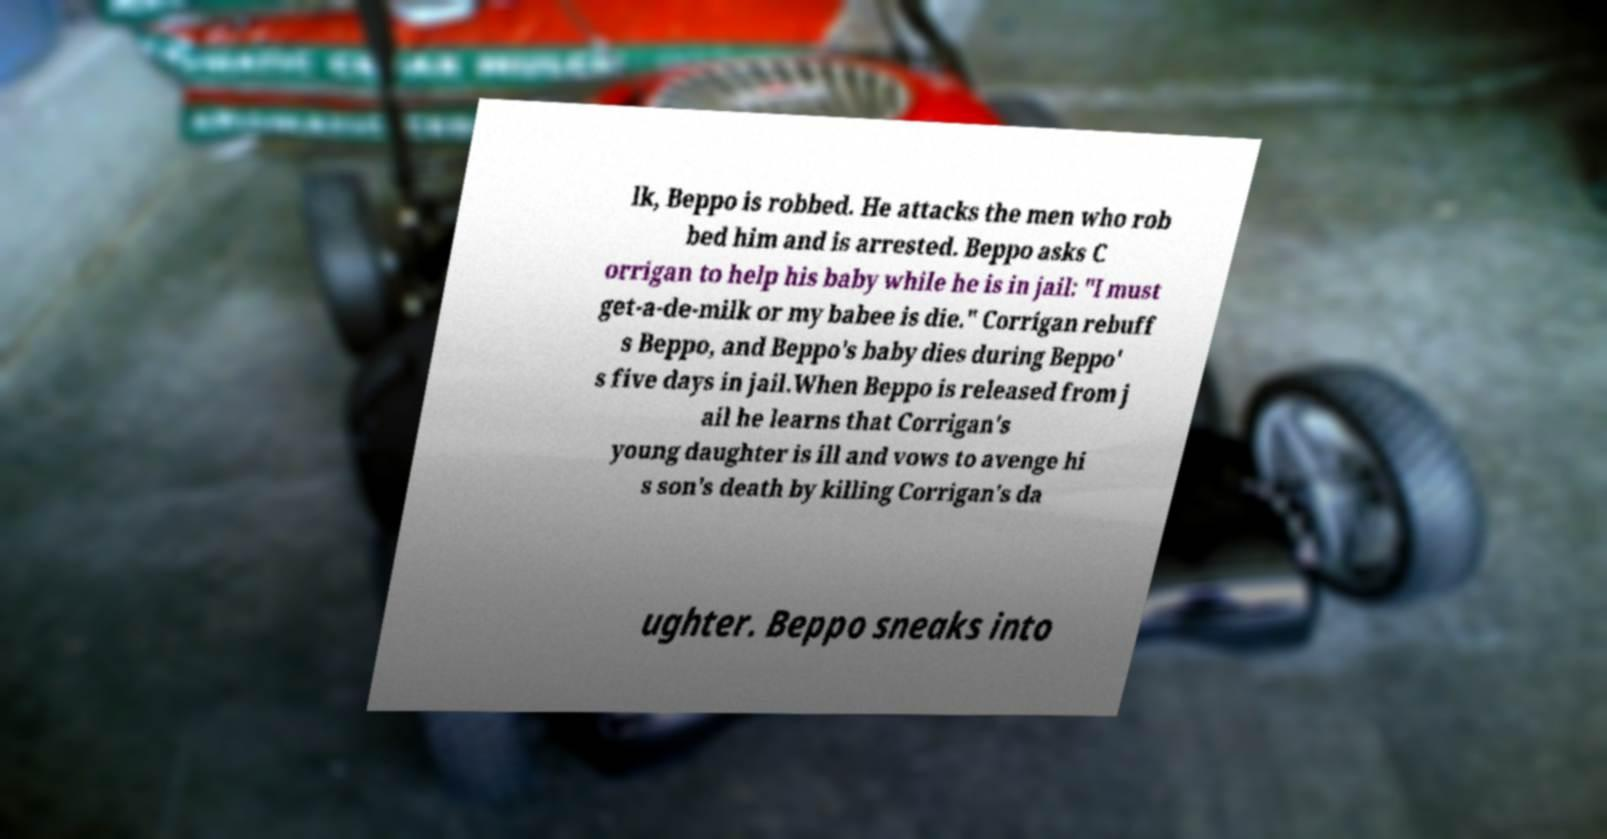For documentation purposes, I need the text within this image transcribed. Could you provide that? lk, Beppo is robbed. He attacks the men who rob bed him and is arrested. Beppo asks C orrigan to help his baby while he is in jail: "I must get-a-de-milk or my babee is die." Corrigan rebuff s Beppo, and Beppo's baby dies during Beppo' s five days in jail.When Beppo is released from j ail he learns that Corrigan's young daughter is ill and vows to avenge hi s son's death by killing Corrigan's da ughter. Beppo sneaks into 